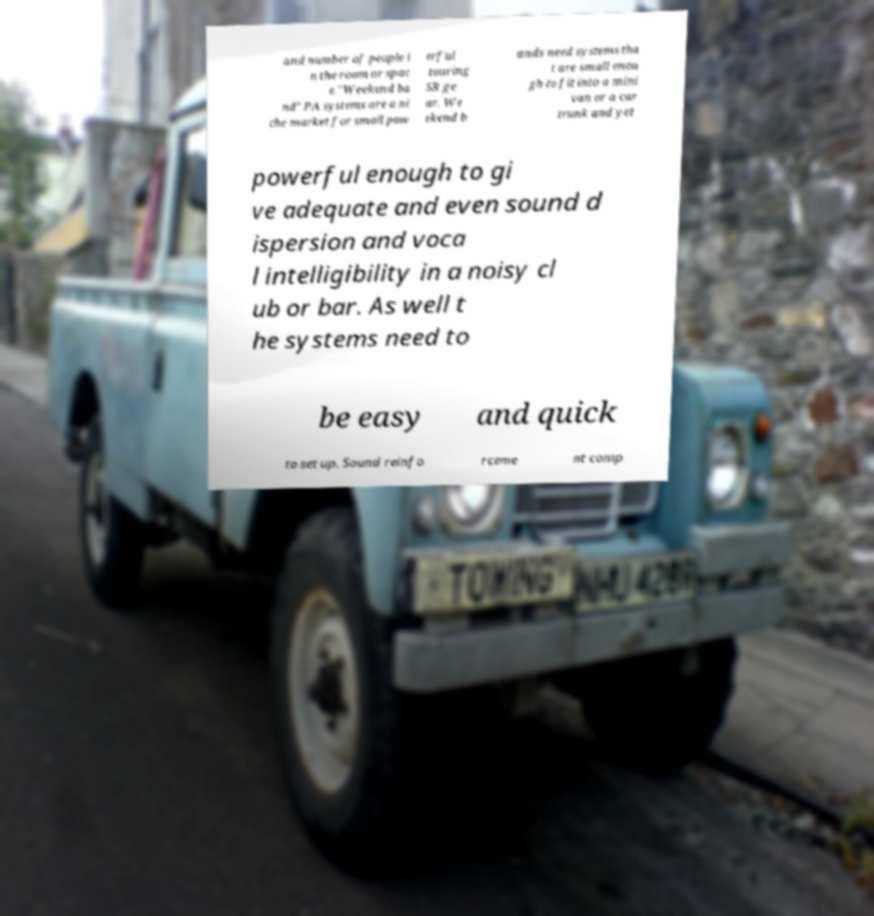Please read and relay the text visible in this image. What does it say? and number of people i n the room or spac e."Weekend ba nd" PA systems are a ni che market for small pow erful touring SR ge ar. We ekend b ands need systems tha t are small enou gh to fit into a mini van or a car trunk and yet powerful enough to gi ve adequate and even sound d ispersion and voca l intelligibility in a noisy cl ub or bar. As well t he systems need to be easy and quick to set up. Sound reinfo rceme nt comp 